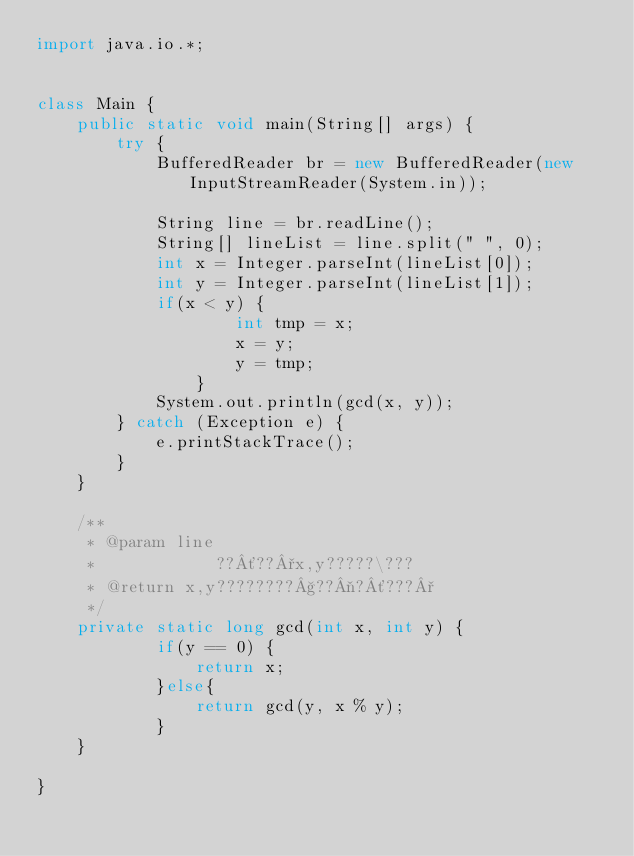Convert code to text. <code><loc_0><loc_0><loc_500><loc_500><_Java_>import java.io.*;


class Main {
    public static void main(String[] args) {
        try {
            BufferedReader br = new BufferedReader(new InputStreamReader(System.in));
            
            String line = br.readLine();
            String[] lineList = line.split(" ", 0);
            int x = Integer.parseInt(lineList[0]);
            int y = Integer.parseInt(lineList[1]);
            if(x < y) {
	    			int tmp = x;
	    			x = y;
	    			y = tmp;
	    		}
            System.out.println(gcd(x, y));
        } catch (Exception e) {
            e.printStackTrace();
        }
    }

    /**
     * @param line
     *            ??´??°x,y?????\???
     * @return x,y????????§??¬?´???°
     */
    private static long gcd(int x, int y) {
    		if(y == 0) {
    			return x;
    		}else{
    			return gcd(y, x % y);
    		}
    }

}</code> 